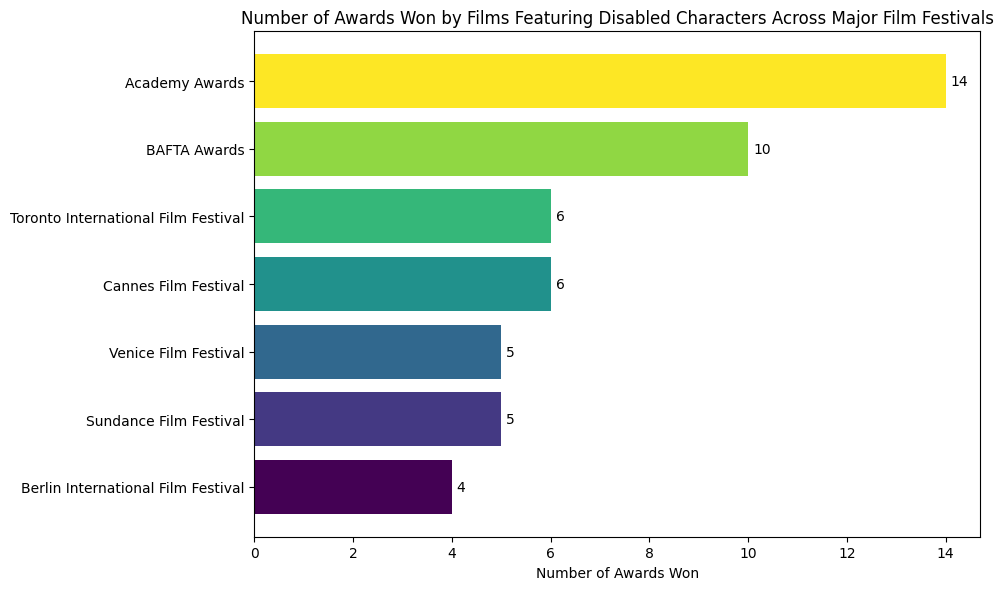Which film festival had the highest number of awards won by films featuring disabled characters? To determine which film festival had the highest number of awards, look for the longest bar in the bar chart.
Answer: Academy Awards Which film festival had the lowest number of awards won by films featuring disabled characters? Identify the shortest bar in the bar chart, which corresponds to the film festival with the fewest awards.
Answer: Berlin International Film Festival Which two film festivals have an equal number of awards won and what is that number? Look for bars with the same length and note the corresponding film festival names and the number of awards they represent.
Answer: Sundance Film Festival and BAFTA Awards, both with 6 awards How does the number of awards won at the Toronto International Film Festival compare to that at the Venice Film Festival? Compare the bar lengths for the Toronto International Film Festival and the Venice Film Festival to see which is longer.
Answer: Toronto International Film Festival has one more award than Venice Film Festival (6 vs. 5) Which film festival's bar is greenish-yellow in color? Look for the bar with a greenish-yellow color and note the corresponding film festival.
Answer: Berlin International Film Festival 